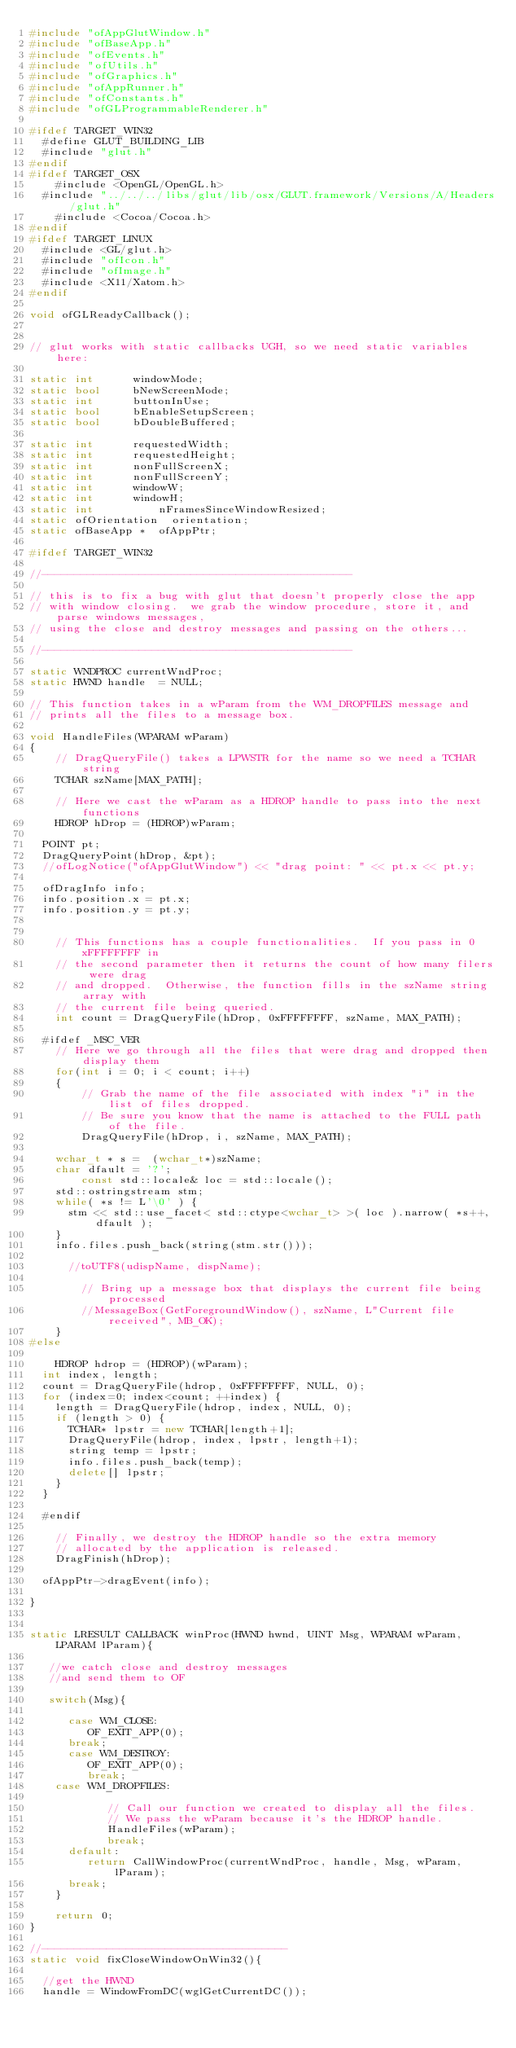<code> <loc_0><loc_0><loc_500><loc_500><_C++_>#include "ofAppGlutWindow.h"
#include "ofBaseApp.h"
#include "ofEvents.h"
#include "ofUtils.h"
#include "ofGraphics.h"
#include "ofAppRunner.h"
#include "ofConstants.h"
#include "ofGLProgrammableRenderer.h"

#ifdef TARGET_WIN32
	#define GLUT_BUILDING_LIB
	#include "glut.h"
#endif
#ifdef TARGET_OSX
    #include <OpenGL/OpenGL.h>
	#include "../../../libs/glut/lib/osx/GLUT.framework/Versions/A/Headers/glut.h"
    #include <Cocoa/Cocoa.h>
#endif
#ifdef TARGET_LINUX
	#include <GL/glut.h>
	#include "ofIcon.h"
	#include "ofImage.h"
	#include <X11/Xatom.h>
#endif

void ofGLReadyCallback();


// glut works with static callbacks UGH, so we need static variables here:

static int			windowMode;
static bool			bNewScreenMode;
static int			buttonInUse;
static bool			bEnableSetupScreen;
static bool			bDoubleBuffered; 

static int			requestedWidth;
static int			requestedHeight;
static int 			nonFullScreenX;
static int 			nonFullScreenY;
static int			windowW;
static int			windowH;
static int          nFramesSinceWindowResized;
static ofOrientation	orientation;
static ofBaseApp *  ofAppPtr;

#ifdef TARGET_WIN32

//------------------------------------------------

// this is to fix a bug with glut that doesn't properly close the app
// with window closing.  we grab the window procedure, store it, and parse windows messages,
// using the close and destroy messages and passing on the others...

//------------------------------------------------

static WNDPROC currentWndProc;
static HWND handle  = NULL;

// This function takes in a wParam from the WM_DROPFILES message and
// prints all the files to a message box.

void HandleFiles(WPARAM wParam)
{
    // DragQueryFile() takes a LPWSTR for the name so we need a TCHAR string
    TCHAR szName[MAX_PATH];

    // Here we cast the wParam as a HDROP handle to pass into the next functions
    HDROP hDrop = (HDROP)wParam;

	POINT pt;
	DragQueryPoint(hDrop, &pt);
	//ofLogNotice("ofAppGlutWindow") << "drag point: " << pt.x << pt.y;

	ofDragInfo info;
	info.position.x = pt.x;
	info.position.y = pt.y;


    // This functions has a couple functionalities.  If you pass in 0xFFFFFFFF in
    // the second parameter then it returns the count of how many filers were drag
    // and dropped.  Otherwise, the function fills in the szName string array with
    // the current file being queried.
    int count = DragQueryFile(hDrop, 0xFFFFFFFF, szName, MAX_PATH);

	#ifdef _MSC_VER
    // Here we go through all the files that were drag and dropped then display them
    for(int i = 0; i < count; i++)
    {
        // Grab the name of the file associated with index "i" in the list of files dropped.
        // Be sure you know that the name is attached to the FULL path of the file.
        DragQueryFile(hDrop, i, szName, MAX_PATH);

		wchar_t * s =  (wchar_t*)szName;
		char dfault = '?';
        const std::locale& loc = std::locale();
		std::ostringstream stm;
		while( *s != L'\0' ) {
			stm << std::use_facet< std::ctype<wchar_t> >( loc ).narrow( *s++, dfault );
		}
		info.files.push_back(string(stm.str()));

			//toUTF8(udispName, dispName);

        // Bring up a message box that displays the current file being processed
        //MessageBox(GetForegroundWindow(), szName, L"Current file received", MB_OK);
    }
#else

    HDROP hdrop = (HDROP)(wParam);
	int index, length;
	count = DragQueryFile(hdrop, 0xFFFFFFFF, NULL, 0);
	for (index=0; index<count; ++index) {
	  length = DragQueryFile(hdrop, index, NULL, 0);
	  if (length > 0) {
	    TCHAR* lpstr = new TCHAR[length+1];
	    DragQueryFile(hdrop, index, lpstr, length+1);
	    string temp = lpstr;
	    info.files.push_back(temp);
	    delete[] lpstr;
	  }
	}

	#endif

    // Finally, we destroy the HDROP handle so the extra memory
    // allocated by the application is released.
    DragFinish(hDrop);

	ofAppPtr->dragEvent(info);

}


static LRESULT CALLBACK winProc(HWND hwnd, UINT Msg, WPARAM wParam, LPARAM lParam){

   //we catch close and destroy messages
   //and send them to OF

   switch(Msg){

      case WM_CLOSE:
         OF_EXIT_APP(0);
      break;
      case WM_DESTROY:
         OF_EXIT_APP(0);
         break;
	  case WM_DROPFILES:

            // Call our function we created to display all the files.
            // We pass the wParam because it's the HDROP handle.
            HandleFiles(wParam);
            break;
      default:
         return CallWindowProc(currentWndProc, handle, Msg, wParam, lParam);
      break;
    }

    return 0;
}

//--------------------------------------
static void fixCloseWindowOnWin32(){

	//get the HWND
	handle = WindowFromDC(wglGetCurrentDC());
</code> 